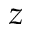Convert formula to latex. <formula><loc_0><loc_0><loc_500><loc_500>z</formula> 